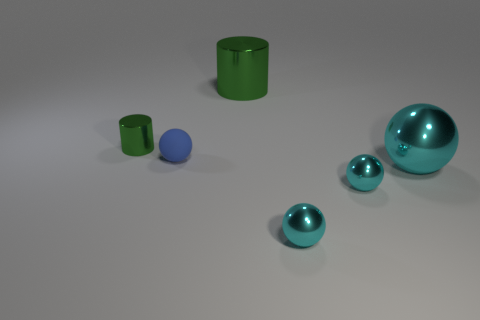Subtract all brown blocks. How many cyan spheres are left? 3 Add 3 cylinders. How many objects exist? 9 Subtract all cylinders. How many objects are left? 4 Subtract all big green shiny things. Subtract all large cyan metal things. How many objects are left? 4 Add 4 tiny metal cylinders. How many tiny metal cylinders are left? 5 Add 1 small shiny objects. How many small shiny objects exist? 4 Subtract 0 purple blocks. How many objects are left? 6 